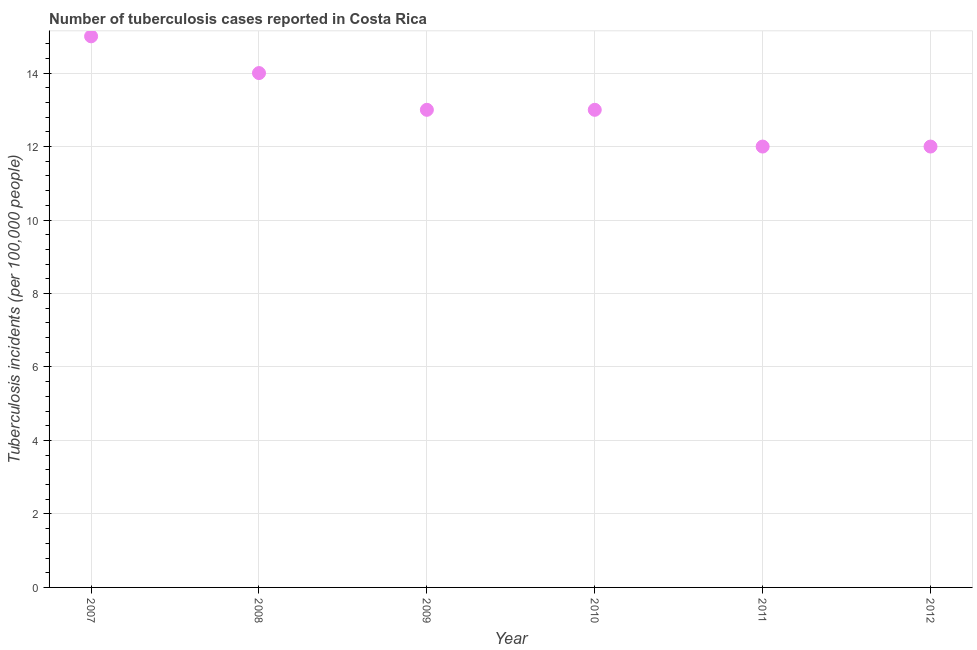What is the number of tuberculosis incidents in 2009?
Provide a short and direct response. 13. Across all years, what is the maximum number of tuberculosis incidents?
Make the answer very short. 15. Across all years, what is the minimum number of tuberculosis incidents?
Your response must be concise. 12. In which year was the number of tuberculosis incidents maximum?
Offer a terse response. 2007. What is the sum of the number of tuberculosis incidents?
Provide a short and direct response. 79. What is the difference between the number of tuberculosis incidents in 2008 and 2010?
Provide a succinct answer. 1. What is the average number of tuberculosis incidents per year?
Give a very brief answer. 13.17. What is the ratio of the number of tuberculosis incidents in 2010 to that in 2012?
Your answer should be very brief. 1.08. What is the difference between the highest and the second highest number of tuberculosis incidents?
Your answer should be very brief. 1. Is the sum of the number of tuberculosis incidents in 2009 and 2011 greater than the maximum number of tuberculosis incidents across all years?
Ensure brevity in your answer.  Yes. What is the difference between the highest and the lowest number of tuberculosis incidents?
Keep it short and to the point. 3. Does the number of tuberculosis incidents monotonically increase over the years?
Offer a terse response. No. How many years are there in the graph?
Make the answer very short. 6. What is the difference between two consecutive major ticks on the Y-axis?
Make the answer very short. 2. Does the graph contain any zero values?
Your answer should be compact. No. Does the graph contain grids?
Offer a very short reply. Yes. What is the title of the graph?
Ensure brevity in your answer.  Number of tuberculosis cases reported in Costa Rica. What is the label or title of the Y-axis?
Keep it short and to the point. Tuberculosis incidents (per 100,0 people). What is the Tuberculosis incidents (per 100,000 people) in 2007?
Your answer should be compact. 15. What is the Tuberculosis incidents (per 100,000 people) in 2008?
Provide a short and direct response. 14. What is the Tuberculosis incidents (per 100,000 people) in 2011?
Make the answer very short. 12. What is the difference between the Tuberculosis incidents (per 100,000 people) in 2007 and 2009?
Your response must be concise. 2. What is the difference between the Tuberculosis incidents (per 100,000 people) in 2007 and 2012?
Your response must be concise. 3. What is the difference between the Tuberculosis incidents (per 100,000 people) in 2008 and 2010?
Provide a succinct answer. 1. What is the difference between the Tuberculosis incidents (per 100,000 people) in 2008 and 2011?
Your response must be concise. 2. What is the difference between the Tuberculosis incidents (per 100,000 people) in 2008 and 2012?
Keep it short and to the point. 2. What is the difference between the Tuberculosis incidents (per 100,000 people) in 2009 and 2010?
Your answer should be very brief. 0. What is the difference between the Tuberculosis incidents (per 100,000 people) in 2009 and 2011?
Your response must be concise. 1. What is the difference between the Tuberculosis incidents (per 100,000 people) in 2011 and 2012?
Your response must be concise. 0. What is the ratio of the Tuberculosis incidents (per 100,000 people) in 2007 to that in 2008?
Keep it short and to the point. 1.07. What is the ratio of the Tuberculosis incidents (per 100,000 people) in 2007 to that in 2009?
Provide a succinct answer. 1.15. What is the ratio of the Tuberculosis incidents (per 100,000 people) in 2007 to that in 2010?
Your response must be concise. 1.15. What is the ratio of the Tuberculosis incidents (per 100,000 people) in 2007 to that in 2011?
Ensure brevity in your answer.  1.25. What is the ratio of the Tuberculosis incidents (per 100,000 people) in 2008 to that in 2009?
Ensure brevity in your answer.  1.08. What is the ratio of the Tuberculosis incidents (per 100,000 people) in 2008 to that in 2010?
Make the answer very short. 1.08. What is the ratio of the Tuberculosis incidents (per 100,000 people) in 2008 to that in 2011?
Provide a succinct answer. 1.17. What is the ratio of the Tuberculosis incidents (per 100,000 people) in 2008 to that in 2012?
Provide a short and direct response. 1.17. What is the ratio of the Tuberculosis incidents (per 100,000 people) in 2009 to that in 2010?
Provide a short and direct response. 1. What is the ratio of the Tuberculosis incidents (per 100,000 people) in 2009 to that in 2011?
Your answer should be compact. 1.08. What is the ratio of the Tuberculosis incidents (per 100,000 people) in 2009 to that in 2012?
Offer a terse response. 1.08. What is the ratio of the Tuberculosis incidents (per 100,000 people) in 2010 to that in 2011?
Offer a very short reply. 1.08. What is the ratio of the Tuberculosis incidents (per 100,000 people) in 2010 to that in 2012?
Offer a terse response. 1.08. 